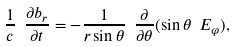<formula> <loc_0><loc_0><loc_500><loc_500>\frac { 1 } { c } \ \frac { \partial b _ { r } } { \partial t } = - \frac { 1 } { r \sin \theta } \ \frac { \partial } { \partial \theta } ( \sin \theta \ E _ { \varphi } ) ,</formula> 